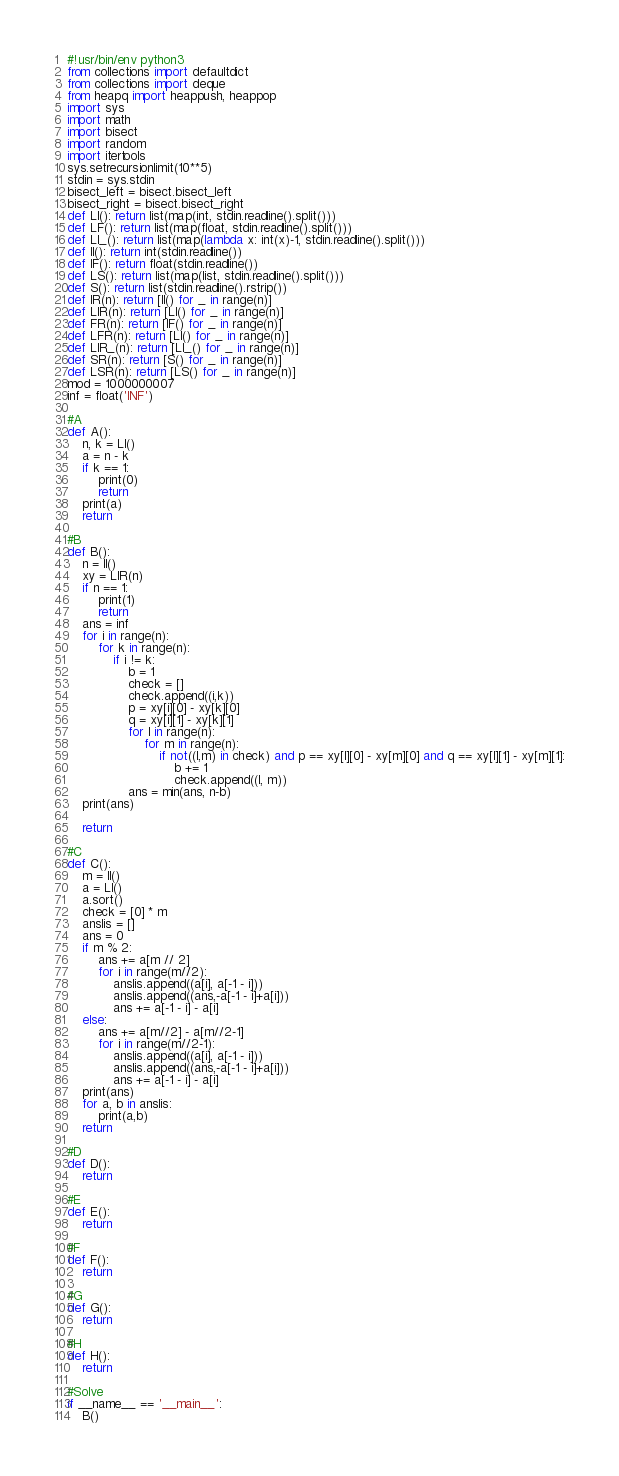Convert code to text. <code><loc_0><loc_0><loc_500><loc_500><_Python_>#!usr/bin/env python3
from collections import defaultdict
from collections import deque
from heapq import heappush, heappop
import sys
import math
import bisect
import random
import itertools
sys.setrecursionlimit(10**5)
stdin = sys.stdin
bisect_left = bisect.bisect_left
bisect_right = bisect.bisect_right
def LI(): return list(map(int, stdin.readline().split()))
def LF(): return list(map(float, stdin.readline().split()))
def LI_(): return list(map(lambda x: int(x)-1, stdin.readline().split()))
def II(): return int(stdin.readline())
def IF(): return float(stdin.readline())
def LS(): return list(map(list, stdin.readline().split()))
def S(): return list(stdin.readline().rstrip())
def IR(n): return [II() for _ in range(n)]
def LIR(n): return [LI() for _ in range(n)]
def FR(n): return [IF() for _ in range(n)]
def LFR(n): return [LI() for _ in range(n)]
def LIR_(n): return [LI_() for _ in range(n)]
def SR(n): return [S() for _ in range(n)]
def LSR(n): return [LS() for _ in range(n)]
mod = 1000000007
inf = float('INF')

#A
def A():
    n, k = LI()
    a = n - k
    if k == 1:
        print(0)
        return
    print(a)
    return

#B
def B():
    n = II()
    xy = LIR(n)
    if n == 1:
        print(1)
        return
    ans = inf
    for i in range(n):
        for k in range(n):
            if i != k:
                b = 1
                check = []
                check.append((i,k))
                p = xy[i][0] - xy[k][0]
                q = xy[i][1] - xy[k][1]
                for l in range(n):
                    for m in range(n):
                        if not((l,m) in check) and p == xy[l][0] - xy[m][0] and q == xy[l][1] - xy[m][1]:
                            b += 1
                            check.append((l, m))
                ans = min(ans, n-b)
    print(ans)

    return

#C
def C():
    m = II()
    a = LI()
    a.sort()
    check = [0] * m
    anslis = []
    ans = 0
    if m % 2:
        ans += a[m // 2]
        for i in range(m//2):
            anslis.append((a[i], a[-1 - i]))
            anslis.append((ans,-a[-1 - i]+a[i]))
            ans += a[-1 - i] - a[i]
    else:
        ans += a[m//2] - a[m//2-1]
        for i in range(m//2-1):
            anslis.append((a[i], a[-1 - i]))
            anslis.append((ans,-a[-1 - i]+a[i]))
            ans += a[-1 - i] - a[i]
    print(ans)
    for a, b in anslis:
        print(a,b)
    return

#D
def D():
    return

#E
def E():
    return

#F
def F():
    return

#G
def G():
    return

#H
def H():
    return

#Solve
if __name__ == '__main__':
    B()
</code> 